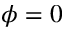<formula> <loc_0><loc_0><loc_500><loc_500>\phi = 0</formula> 